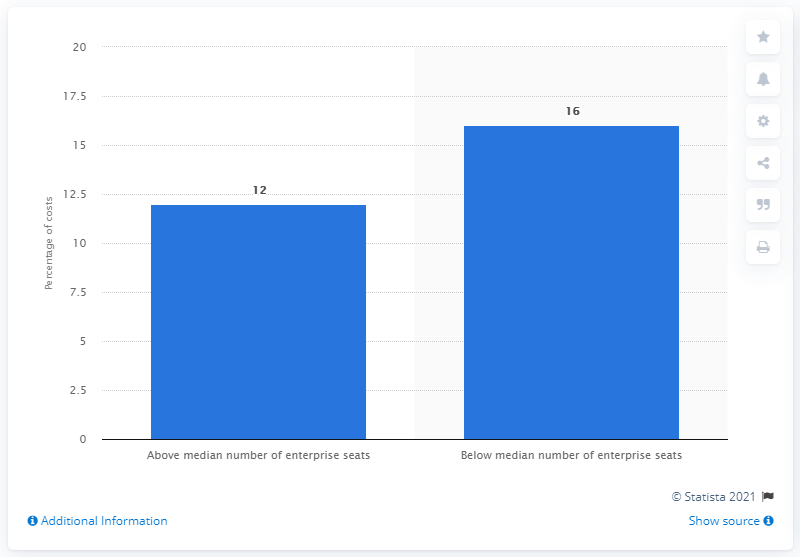Identify some key points in this picture. The percentage of cyber crime costs incurred by companies with fewer than 13.251 enterprise seats was 16%. 